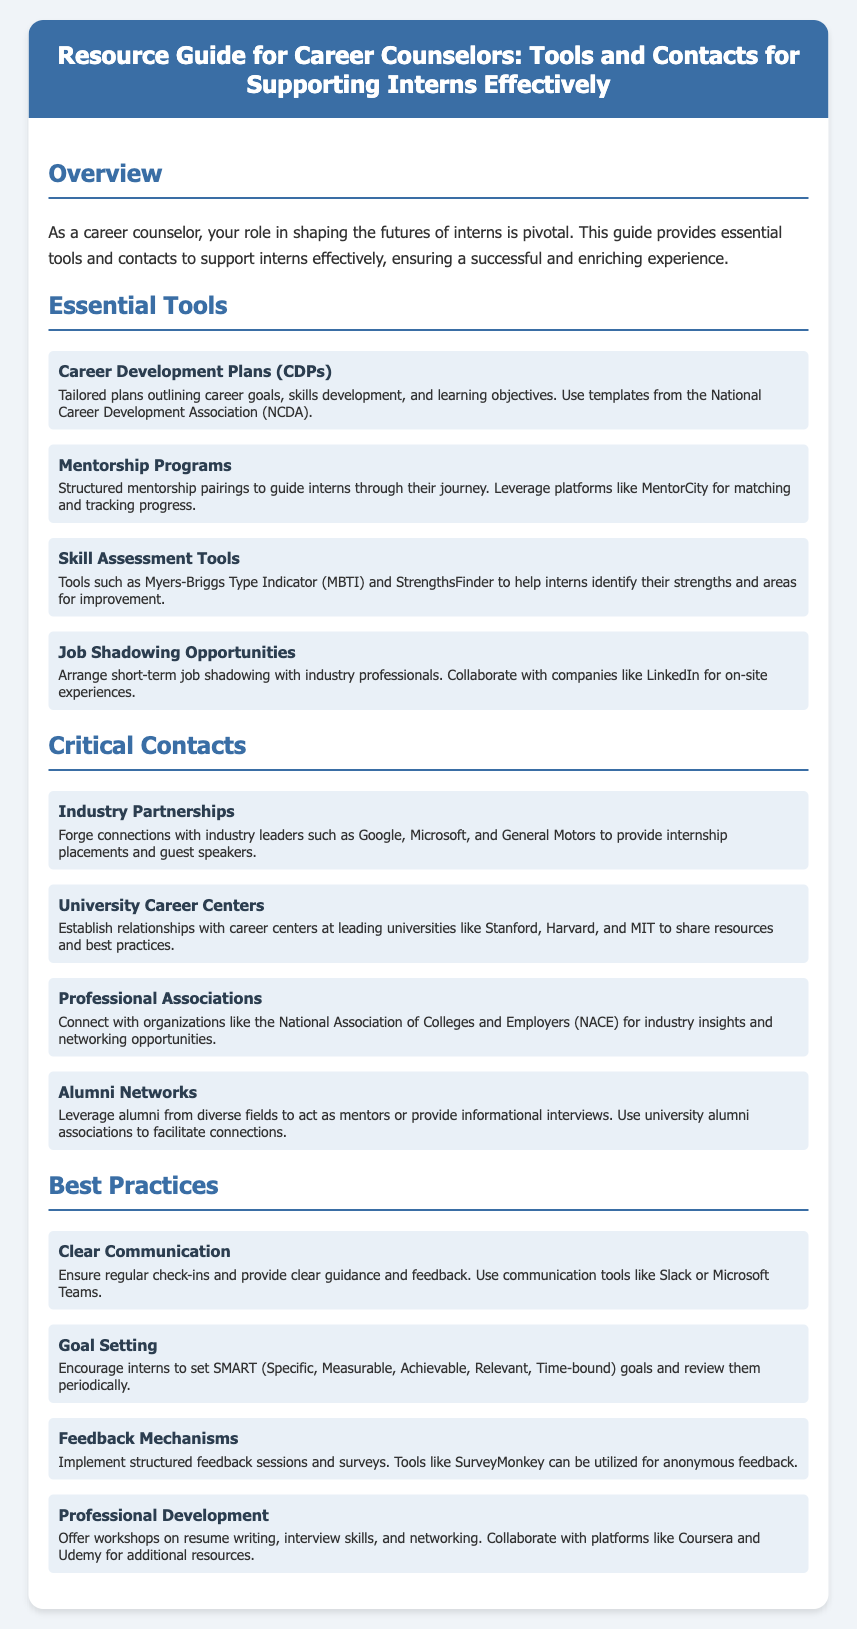What is the title of the guide? The title of the guide is presented prominently in the header section of the document.
Answer: Resource Guide for Career Counselors: Tools and Contacts for Supporting Interns Effectively How many essential tools are listed in the document? The number of essential tools can be determined by counting the items in the "Essential Tools" section of the document.
Answer: Four What program can be used for structured mentorship pairings? The document specifically mentions a platform that is used for mentorship pairing.
Answer: MentorCity Which assessment tool is mentioned for skills evaluation? The document lists specific tools that can help identify strengths and areas for improvement for interns.
Answer: Myers-Briggs Type Indicator Name one of the professional associations listed in the document. The document includes various associations that career counselors can connect with for industry insights.
Answer: National Association of Colleges and Employers What type of goals should interns be encouraged to set? The document specifies the methodology for goal setting for interns.
Answer: SMART Which tool is suggested for collecting anonymous feedback? The document provides a recommendation for a specific tool to implement structured feedback sessions.
Answer: SurveyMonkey What is one best practice mentioned for ensuring effective communication? The document highlights clear communication as an essential practice and suggests tools to facilitate it.
Answer: Regular check-ins How many critical contacts are provided in the guide? The number of contacts can be confirmed by counting the items in the "Critical Contacts" section of the document.
Answer: Four 